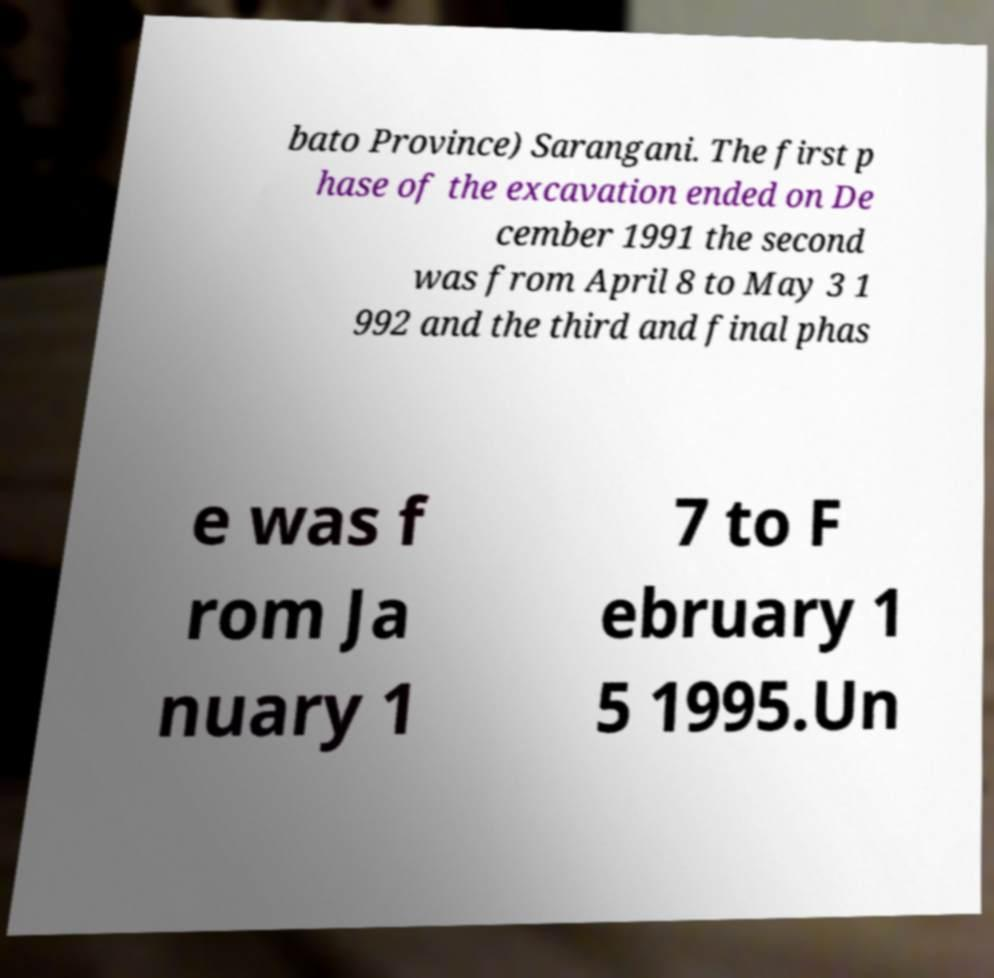There's text embedded in this image that I need extracted. Can you transcribe it verbatim? bato Province) Sarangani. The first p hase of the excavation ended on De cember 1991 the second was from April 8 to May 3 1 992 and the third and final phas e was f rom Ja nuary 1 7 to F ebruary 1 5 1995.Un 